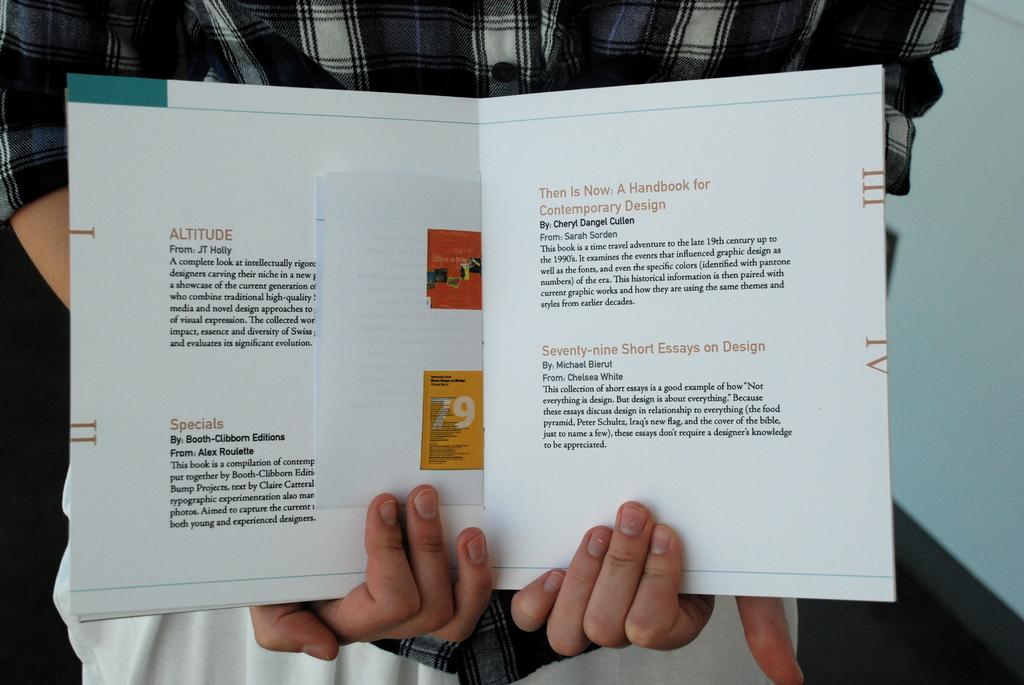Which one is by cheryl dangel cullen?
Your answer should be compact. Then is now: a handbook for contemporary design. 